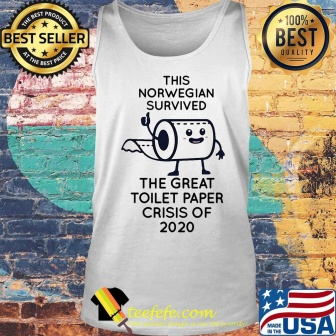Picture this tank top as part of a time capsule. What would future generations think of it? Future generations opening the time capsule might view this tank top as an intriguing snapshot of life during the early 21st century. They would see it as a relic from a time when the world faced an unprecedented global pandemic, embodied by the anthropomorphized toilet paper roll and the humorous text referencing the 2020 shortages. The tank top's wit and satire would speak to humanity's capacity to find light in the darkest times. The contextual elements, such as the 'best seller' and '100% best quality' badges, and the American flag, would offer insights into consumer culture and patriotic sentiments of the era. Ultimately, future generations might perceive this tank top as a symbol of resilience, creativity, and the human spirit's indomitable ability to laugh and live through challenging periods. 